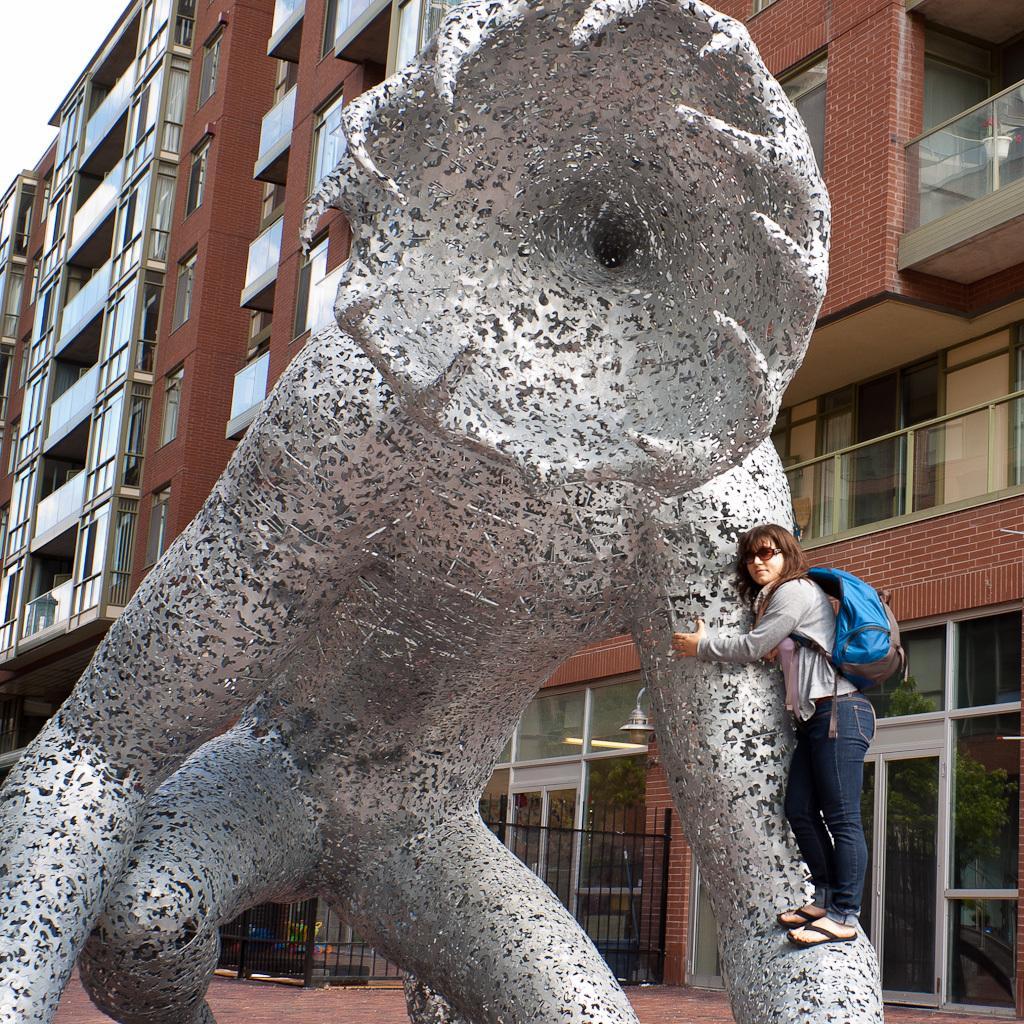How would you summarize this image in a sentence or two? In the image I can see a person who is wearing the backpack and standing on the statue and also I can see some buildings. 